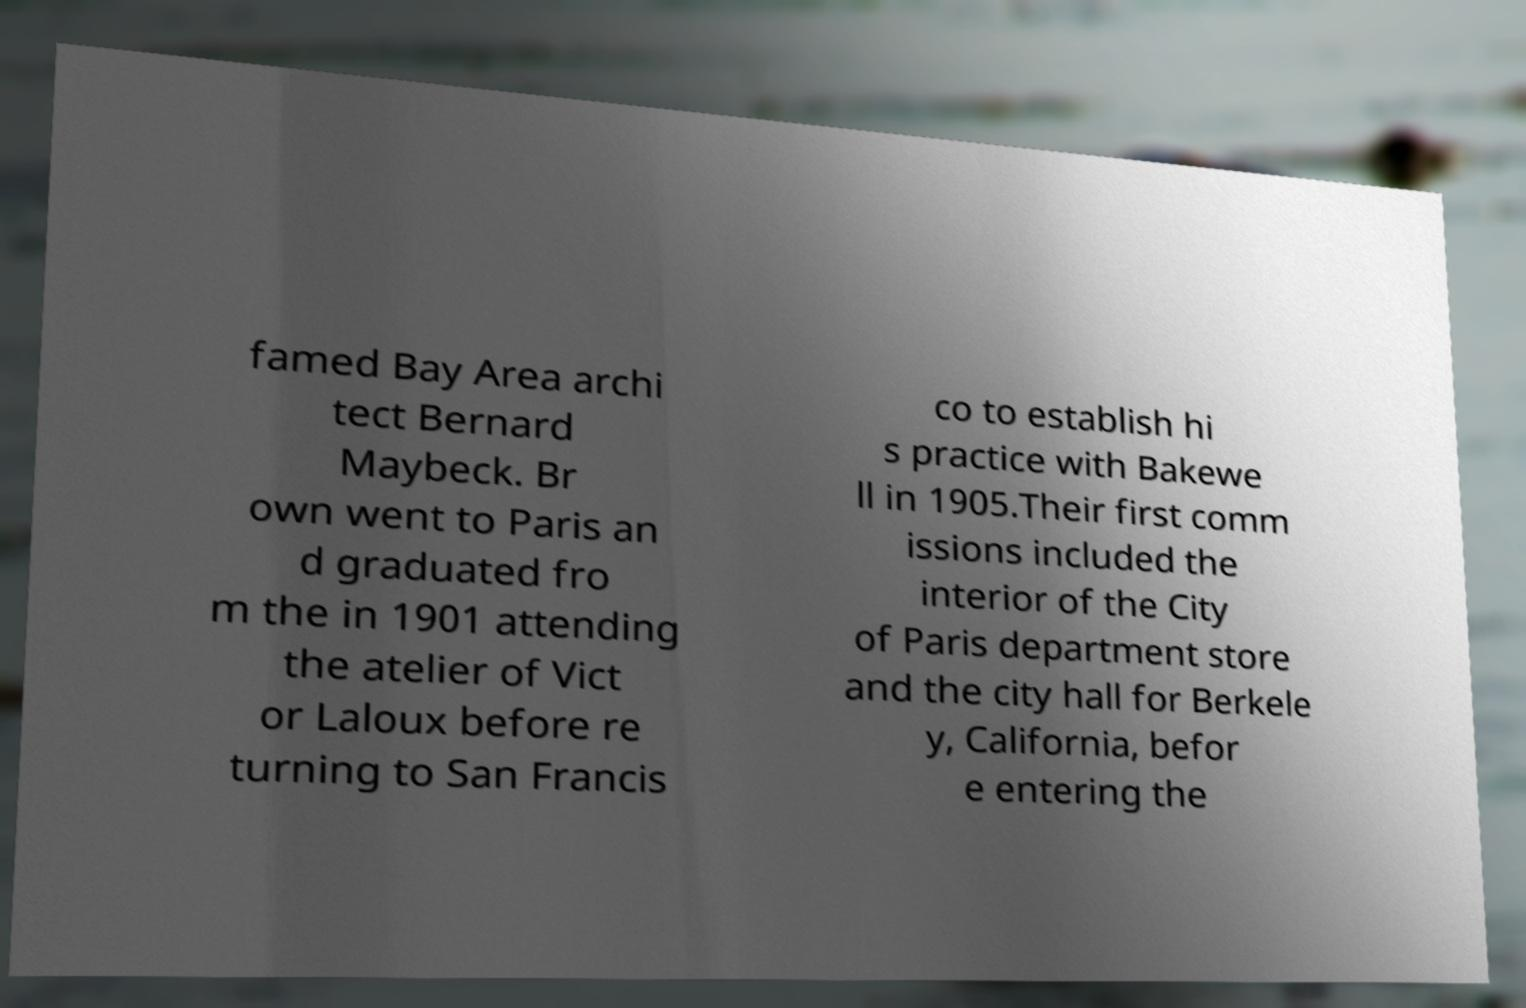Could you assist in decoding the text presented in this image and type it out clearly? famed Bay Area archi tect Bernard Maybeck. Br own went to Paris an d graduated fro m the in 1901 attending the atelier of Vict or Laloux before re turning to San Francis co to establish hi s practice with Bakewe ll in 1905.Their first comm issions included the interior of the City of Paris department store and the city hall for Berkele y, California, befor e entering the 